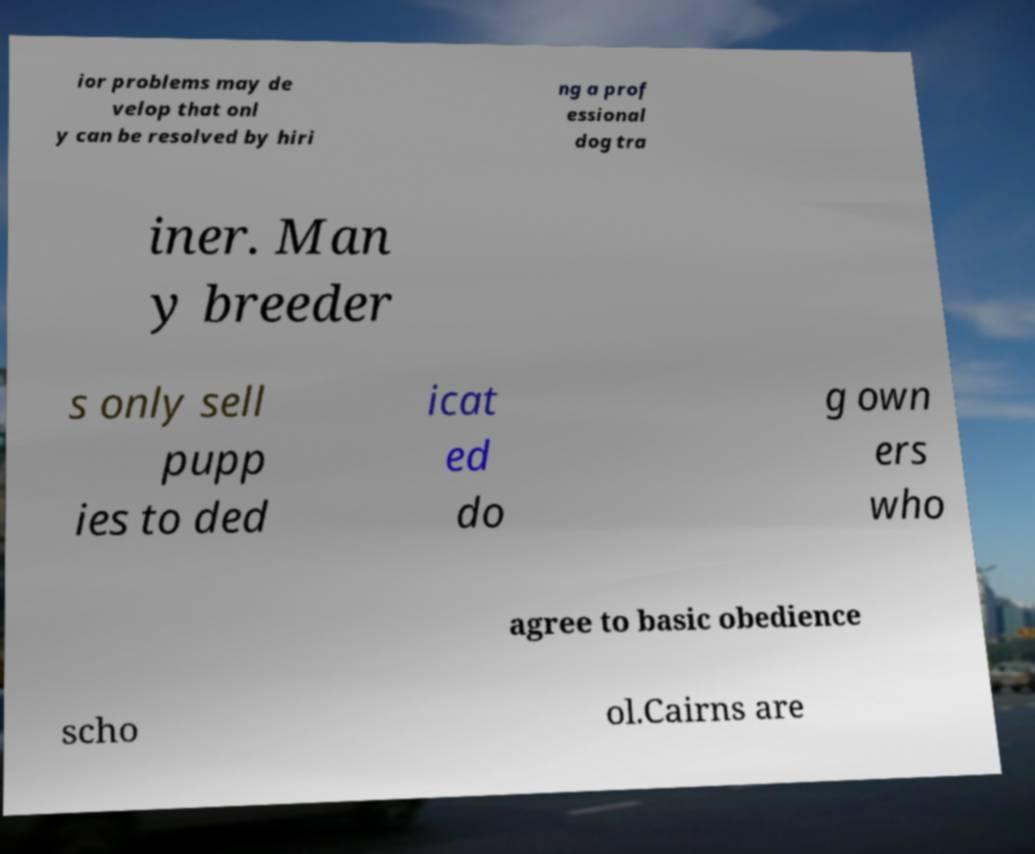What messages or text are displayed in this image? I need them in a readable, typed format. ior problems may de velop that onl y can be resolved by hiri ng a prof essional dog tra iner. Man y breeder s only sell pupp ies to ded icat ed do g own ers who agree to basic obedience scho ol.Cairns are 